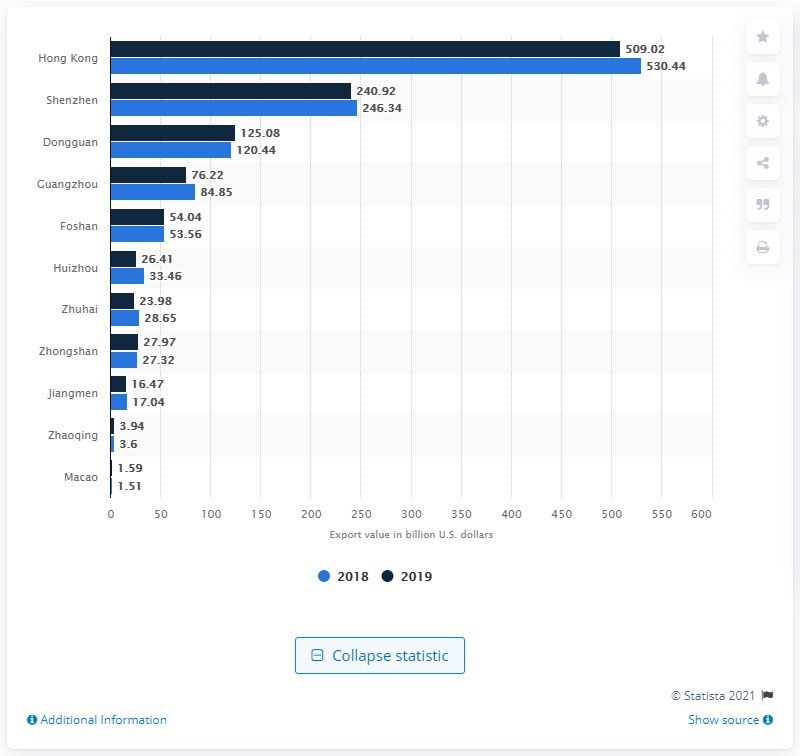Specify some key components in this picture. In 2019, merchandise goods with a value of approximately 509 billion U.S. dollars were exported from Hong Kong. In 2019, the value of merchandise goods exported from Hong Kong was approximately HKD 509.02 billion. 